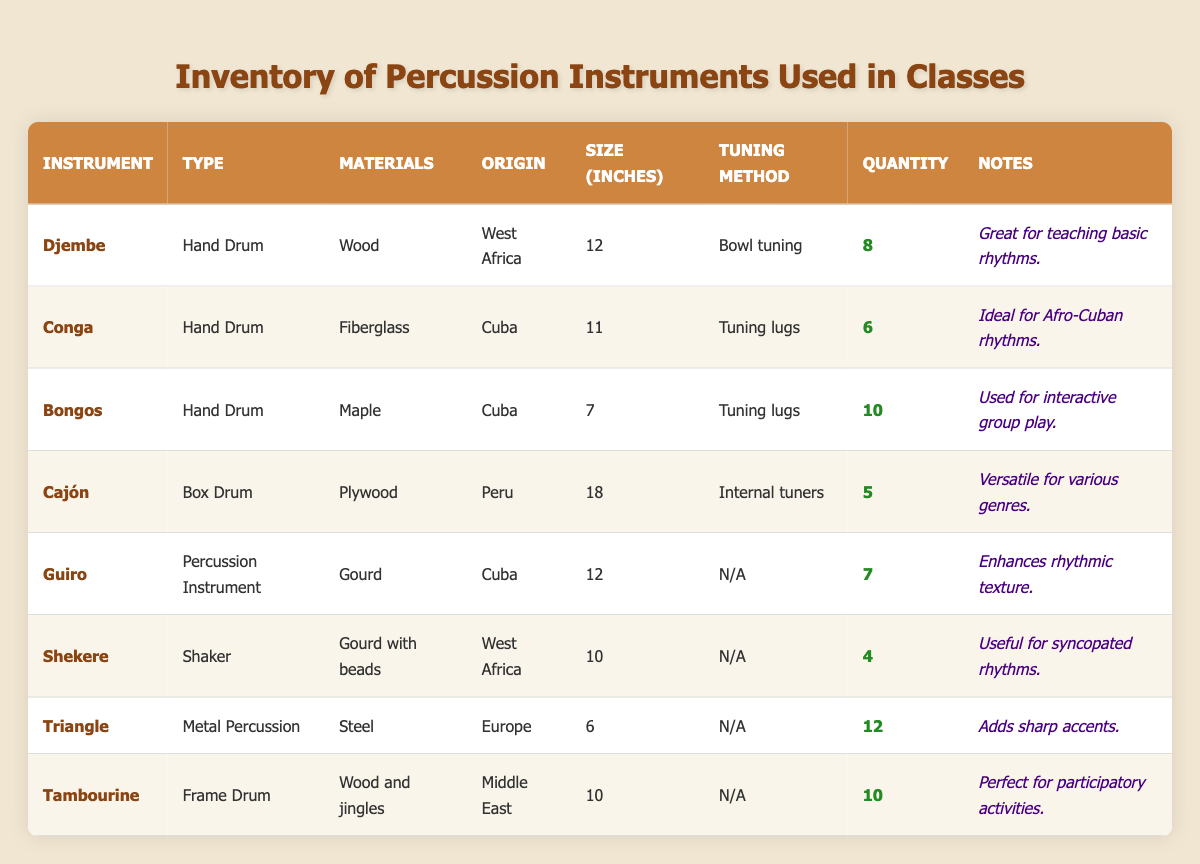What is the quantity of Congas in the inventory? The table lists the quantity of Congas in the "Quantity" column for the instrument "Conga". There are 6 Congas available.
Answer: 6 How many total hand drums are there in the inventory? The hand drums listed are Djembe, Conga, Bongos, and Cajón. To find the total quantity, add them: 8 (Djembe) + 6 (Conga) + 10 (Bongos) + 5 (Cajón) = 29.
Answer: 29 What material is used for the Bongos? The "Materials" column for the Bongos entry indicates they are made of Maple.
Answer: Maple Is the Shekere used for syncopated rhythms? The notes for the Shekere specifically mention it is useful for syncopated rhythms, confirming it is indeed used for that purpose.
Answer: Yes Which instrument has the largest size in inches? Compare the size values from the "Size (inches)" column: Djembe 12, Conga 11, Bongos 7, Cajón 18, Guiro 12, Shekere 10, Triangle 6, and Tambourine 10. The Cajón has the largest size at 18 inches.
Answer: Cajón How many Triangle instruments are there compared to the Shekere? The quantity of Triangle instruments is 12 and Shekere is 4. The difference is calculated as 12 (Triangle) - 4 (Shekere) = 8 more Triangle instruments than Shekere.
Answer: 8 Which percussion instrument from Cuba has the largest quantity? The table shows that both Congas and Bongos are from Cuba with quantities of 6 and 10 respectively. Bongos has the larger quantity at 10.
Answer: Bongos What is the average size of all instruments in the inventory? The sizes are: 12, 11, 7, 18, 12, 10, 6, and 10. To find the average, sum these sizes: 12 + 11 + 7 + 18 + 12 + 10 + 6 + 10 = 96. There are 8 instruments, so the average size is 96/8 = 12.
Answer: 12 Are there more instruments made of wood than those made of fiberglass? The instruments made of wood are Djembe, Tambourine, and Cajón. Their quantities are 8, 10, and 5, respectively, totaling 23. The only instrument made of fiberglass is the Conga, which has a quantity of 6. Thus, there are more wooden instruments.
Answer: Yes What kind of materials are used for instruments originating from West Africa? The instruments from West Africa are the Djembe and Shekere. Djembe is made of Wood, and Shekere is made from Gourd with beads.
Answer: Wood and Gourd with beads How many more Triangle instruments are there than Congas? There are 12 Triangle instruments and 6 Congas. The difference is 12 (Triangle) - 6 (Conga) = 6 more Triangle instruments.
Answer: 6 